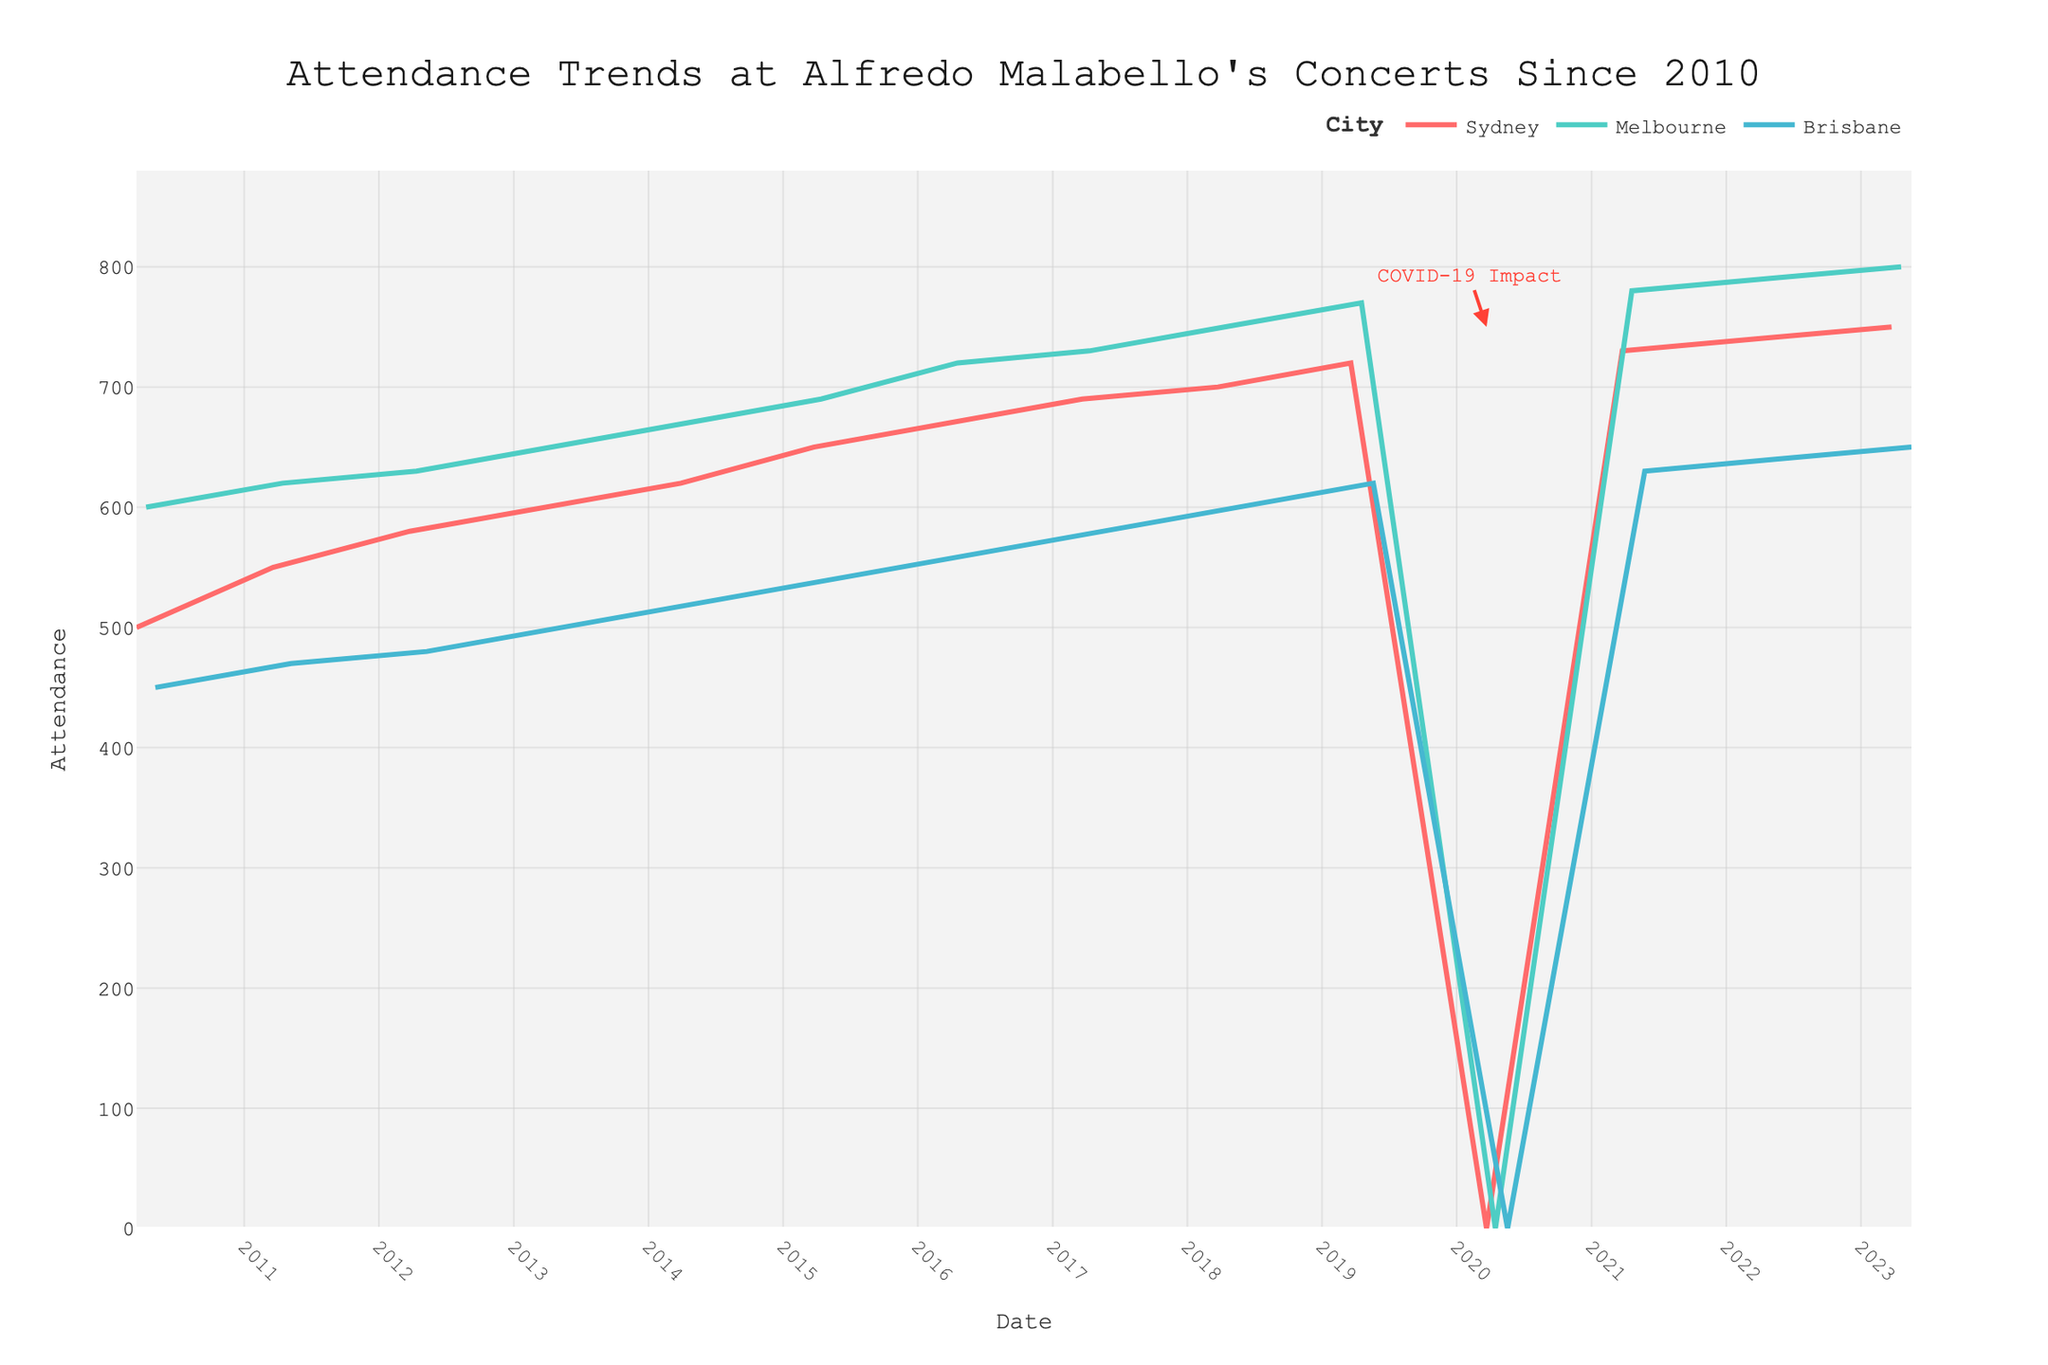What is the title of the figure? The title of a figure is typically displayed at the top and serves as a brief summary of what the figure represents. In this case, the title "Attendance Trends at Alfredo Malabello's Concerts Since 2010" can be seen clearly at the top of the plot.
Answer: Attendance Trends at Alfredo Malabello's Concerts Since 2010 How many cities are represented in the plot? The plot uses different colored lines to represent different cities. Looking at the legend, three different colors are used, each corresponding to one of the cities: Sydney, Melbourne, and Brisbane.
Answer: 3 What color is used to represent Melbourne? By referring to the legend provided in the plot, we can see that Melbourne is represented by the color green (a shade close to teal).
Answer: Green In which year did the concerts have zero attendance in all cities? By following the x-axis from 2010 onward, there is a significant drop to zero attendance in 2020 for Sydney, Melbourne, and Brisbane. The annotation "COVID-19 Impact" near the data points in 2020 further indicates the cause.
Answer: 2020 What is the range of attendance values on the y-axis? The y-axis shows the range of attendance values. Upon inspection, the lowest value is 0, and the highest value slightly above 800 (close to 850 is possible, but this depends on yaxis['range']). Consider the highest non-zero value, which is 800, as the upper limit.
Answer: 0 to about 850 Which city had the highest attendance, and in which year did it occur? To determine this, inspect the peak points for all cities. The maximum attendance value (800) is observed for Melbourne in the year 2023.
Answer: Melbourne, 2023 How did the attendance in Brisbane change from 2010 to 2013? Looking at Brisbane's trend from 2010 (450) to 2013 (500), there is a clear increase. Calculating the difference: 500 - 450 = 50. Hence, the attendance increased by 50.
Answer: Increased by 50 Which city had the least increase in attendance from 2010 to 2023? Evaluating the attendance data for each city across the whole period:
- Sydney: 750 - 500 = 250
- Melbourne: 800 - 600 = 200
- Brisbane: 650 - 450 = 200
The least increase is for Melbourne and Brisbane at 200.
Answer: Melbourne and Brisbane What is the average attendance in Sydney across the years? To find the average attendance in Sydney, add the annual attendance values and divide by the number of years (13 excluding 0's):
(500 + 550 + 580 + 600 + 620 + 650 + 670 + 690 + 700 + 720 + 730 + 740 + 750) / 13 = 8500 / 13 = 653.8
Answer: 653.8 Which year saw the highest combined attendance across all cities? Sum the attendance for each year and compare:
- 2022: 740 (Sydney) + 790 (Melbourne) + 640 (Brisbane) = 2170
2022 has the highest combined attendance with 2170.
Answer: 2022 